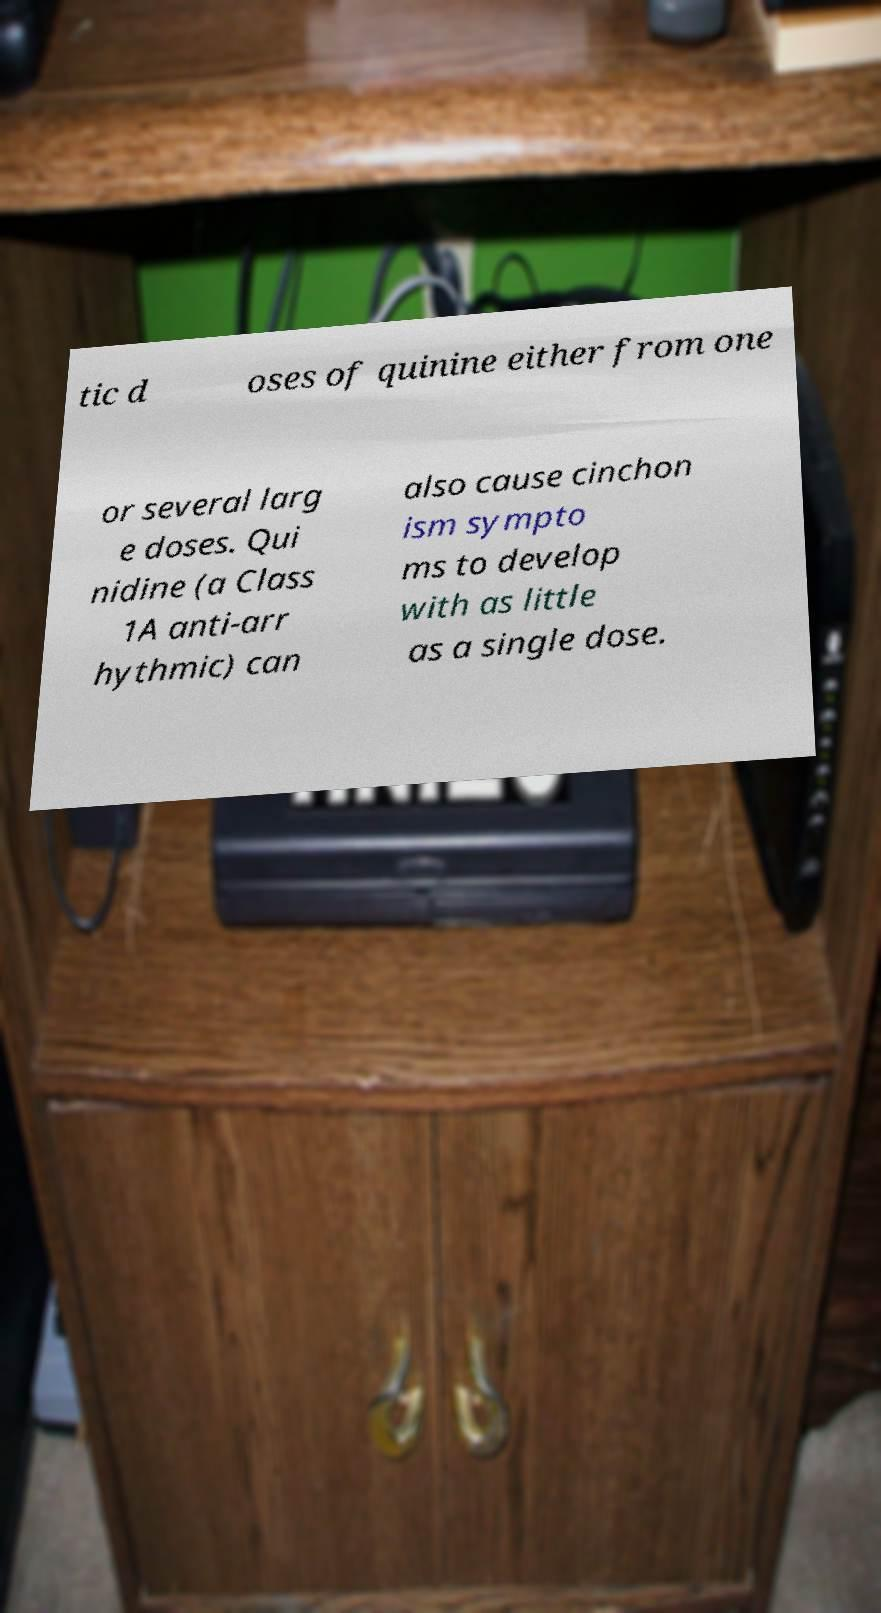Please read and relay the text visible in this image. What does it say? tic d oses of quinine either from one or several larg e doses. Qui nidine (a Class 1A anti-arr hythmic) can also cause cinchon ism sympto ms to develop with as little as a single dose. 